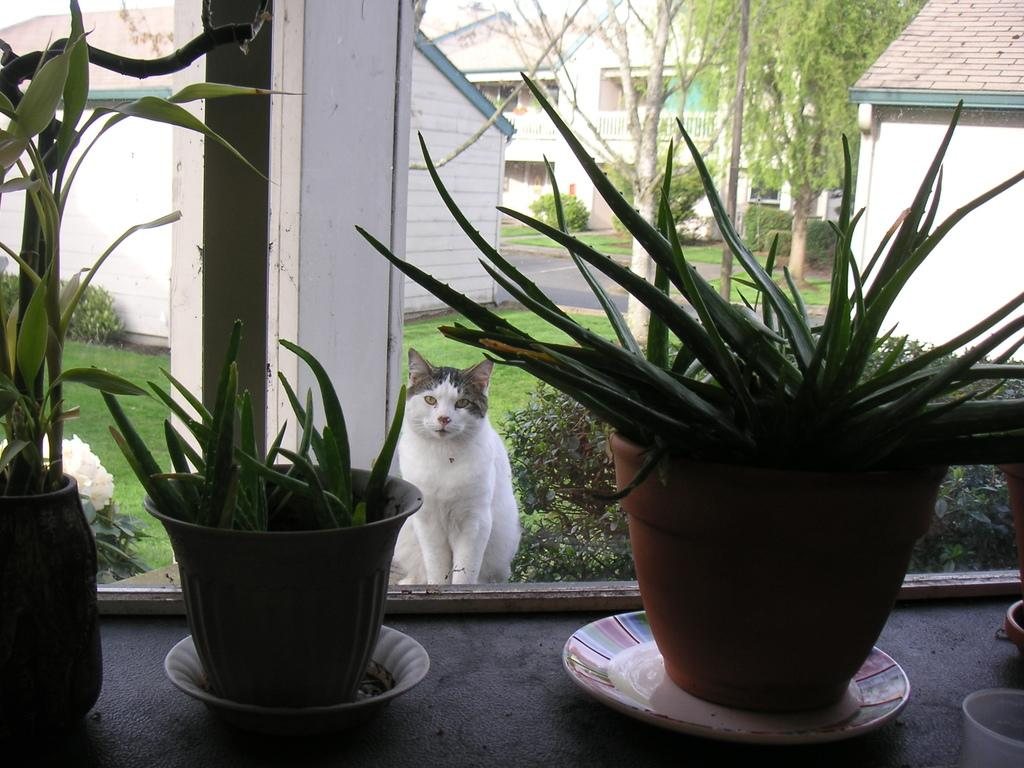How many pots are visible in the image? There are three pots in the image. What type of animal is present in the image? There is a cat in the image. Where is the cat located in relation to the pots? The cat is behind one of the pots. What can be seen in the background of the image? Trees, plants, and houses are present in the background of the image. What is the rate of the police car passing by in the image? There is no police car present in the image, so it is not possible to determine the rate at which it might be passing by. 